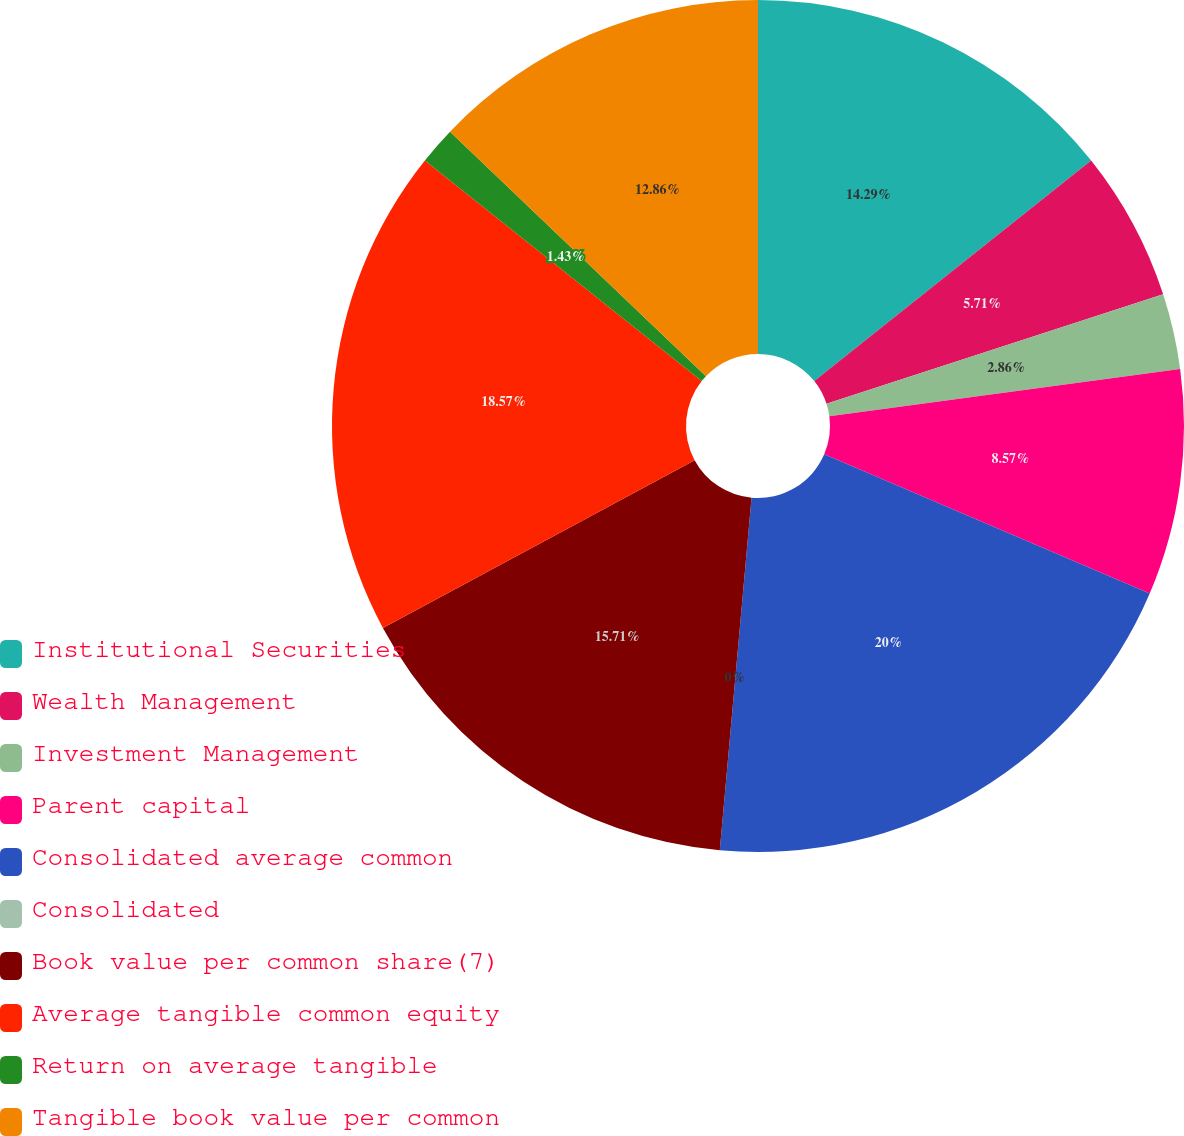Convert chart to OTSL. <chart><loc_0><loc_0><loc_500><loc_500><pie_chart><fcel>Institutional Securities<fcel>Wealth Management<fcel>Investment Management<fcel>Parent capital<fcel>Consolidated average common<fcel>Consolidated<fcel>Book value per common share(7)<fcel>Average tangible common equity<fcel>Return on average tangible<fcel>Tangible book value per common<nl><fcel>14.29%<fcel>5.71%<fcel>2.86%<fcel>8.57%<fcel>20.0%<fcel>0.0%<fcel>15.71%<fcel>18.57%<fcel>1.43%<fcel>12.86%<nl></chart> 